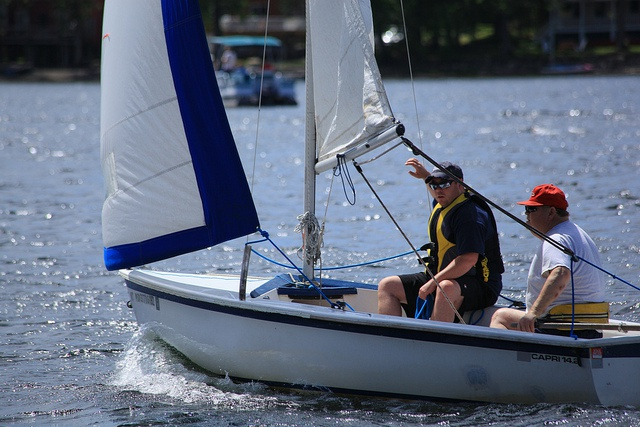Describe the objects in this image and their specific colors. I can see boat in black, gray, and darkblue tones, people in black, brown, and maroon tones, people in black, gray, and maroon tones, and boat in black, gray, blue, and navy tones in this image. 